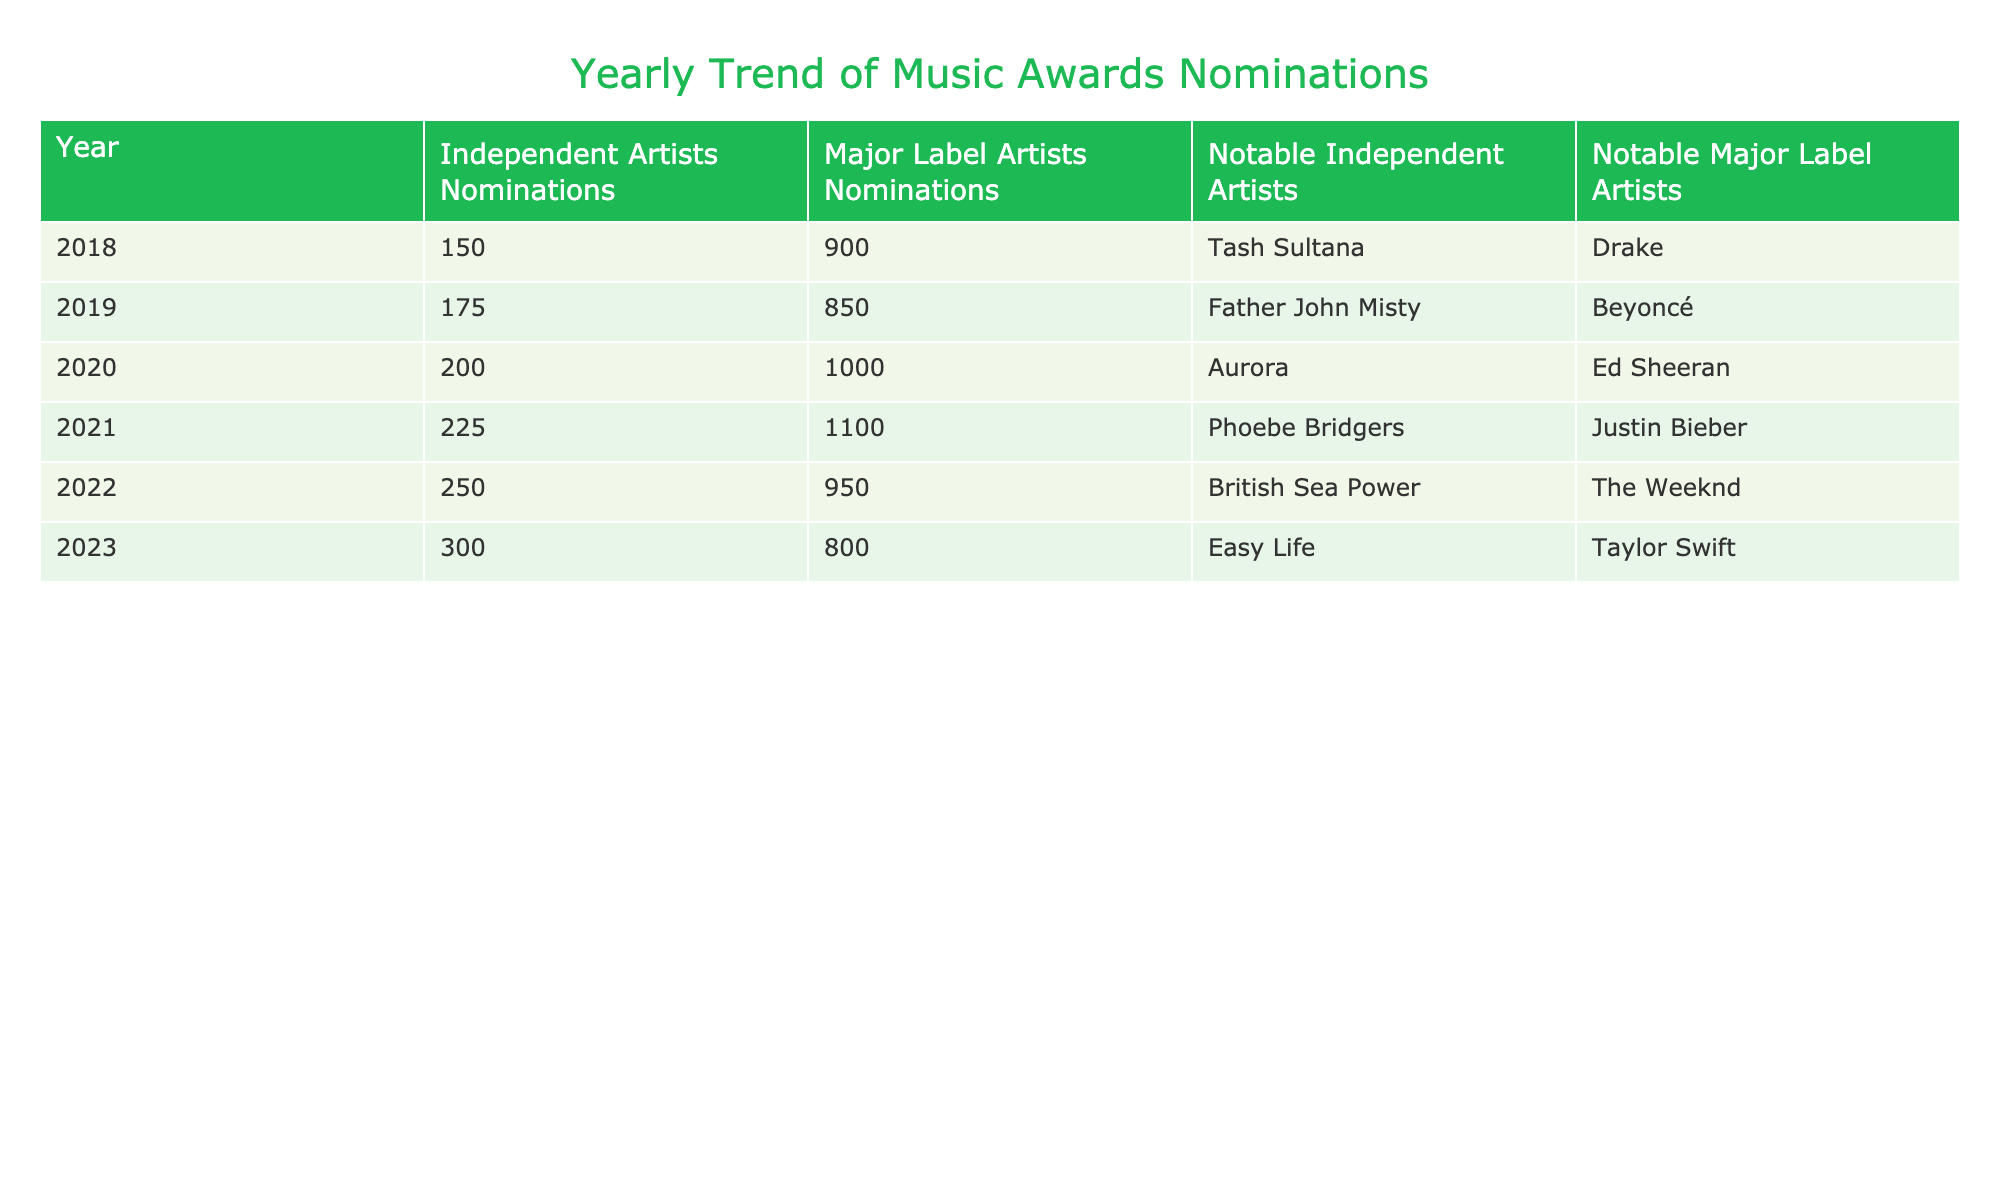What year saw the highest number of nominations for independent artists? In the table, I can see that the number of nominations for independent artists increased steadily until 2023. The highest value is in the year 2023, with 300 nominations.
Answer: 2023 What is the difference in nominations between major label artists and independent artists in 2021? Referring to the table, in 2021, independent artists received 225 nominations, while major label artists got 1100 nominations. The difference is calculated as 1100 - 225 = 875.
Answer: 875 Did independent artists ever have more nominations than major label artists? I can check the table for all years. In every recorded year (2018 to 2023), the nominations for independent artists are consistently lower than for major label artists. Thus, the answer is no.
Answer: No What was the average number of nominations for major label artists from 2018 to 2023? For major label artists, the nominations are 900, 850, 1000, 1100, 950, and 800 over six years. First, sum these values: 900 + 850 + 1000 + 1100 + 950 + 800 = 5100. Then, divide by the number of years: 5100 / 6 = 850. The average is 850.
Answer: 850 Which notable independent artist had the most nominations in 2022? Referring to the table for the year 2022, independent artists had 250 nominations and the notable independent artist listed was British Sea Power. Since they are the only independent artist noted that year, they had the most.
Answer: British Sea Power What trend can be observed in the nominations for independent artists from 2018 to 2023? Looking at the table, the number of nominations for independent artists shows a consistent increase year by year: 150 in 2018, rising to 300 in 2023. This indicates a positive upward trend in nominations for independent artists.
Answer: Consistent increase How many more nominations did major label artists receive than independent artists in 2020? In 2020, the nominations for independent artists were 200, and for major label artists, it was 1000. The difference is 1000 - 200 = 800.
Answer: 800 Which year had the highest count of major label artist nominations? By reviewing the numbers for major label artist nominations, the highest count appears to be 1100 in the year 2021.
Answer: 2021 Is there a year where the nominations for independent artists declined compared to the previous year? Checking the table, each year shows an increase in independent artist nominations. The counts go from 150 in 2018 to 300 in 2023 without any decline. The answer is no.
Answer: No 